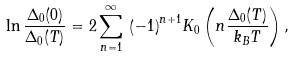<formula> <loc_0><loc_0><loc_500><loc_500>\ln \frac { \Delta _ { 0 } ( 0 ) } { \Delta _ { 0 } ( T ) } = 2 \sum _ { n = 1 } ^ { \infty } \, { \left ( - 1 \right ) } ^ { n + 1 } K _ { 0 } \left ( n \frac { \Delta _ { 0 } ( T ) } { k _ { B } T } \right ) ,</formula> 